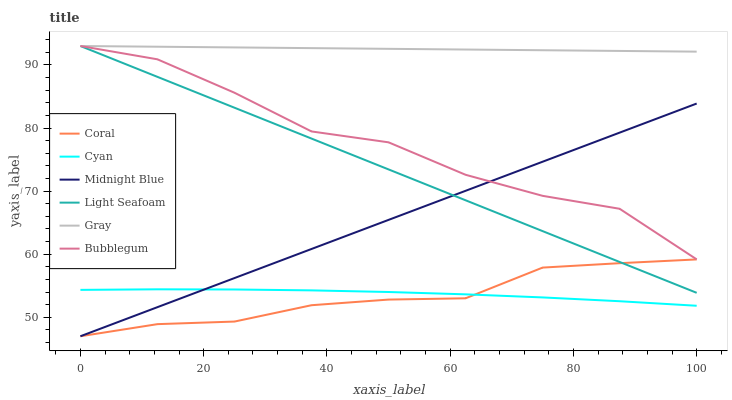Does Coral have the minimum area under the curve?
Answer yes or no. Yes. Does Gray have the maximum area under the curve?
Answer yes or no. Yes. Does Midnight Blue have the minimum area under the curve?
Answer yes or no. No. Does Midnight Blue have the maximum area under the curve?
Answer yes or no. No. Is Midnight Blue the smoothest?
Answer yes or no. Yes. Is Bubblegum the roughest?
Answer yes or no. Yes. Is Coral the smoothest?
Answer yes or no. No. Is Coral the roughest?
Answer yes or no. No. Does Midnight Blue have the lowest value?
Answer yes or no. Yes. Does Bubblegum have the lowest value?
Answer yes or no. No. Does Light Seafoam have the highest value?
Answer yes or no. Yes. Does Midnight Blue have the highest value?
Answer yes or no. No. Is Cyan less than Light Seafoam?
Answer yes or no. Yes. Is Bubblegum greater than Coral?
Answer yes or no. Yes. Does Coral intersect Light Seafoam?
Answer yes or no. Yes. Is Coral less than Light Seafoam?
Answer yes or no. No. Is Coral greater than Light Seafoam?
Answer yes or no. No. Does Cyan intersect Light Seafoam?
Answer yes or no. No. 